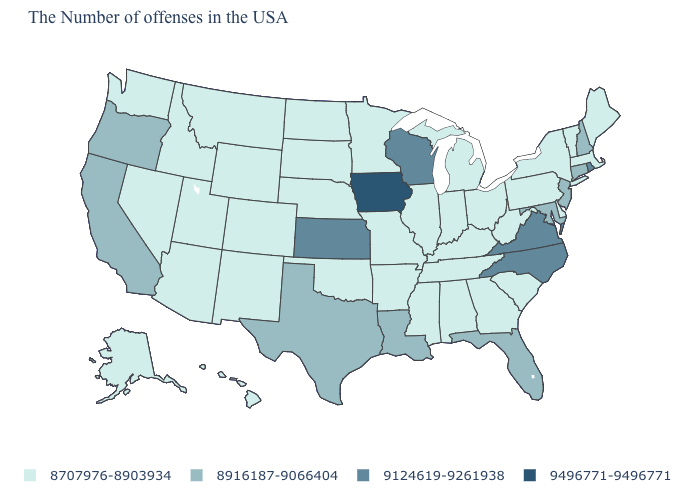What is the highest value in the South ?
Answer briefly. 9124619-9261938. Name the states that have a value in the range 8707976-8903934?
Write a very short answer. Maine, Massachusetts, Vermont, New York, Delaware, Pennsylvania, South Carolina, West Virginia, Ohio, Georgia, Michigan, Kentucky, Indiana, Alabama, Tennessee, Illinois, Mississippi, Missouri, Arkansas, Minnesota, Nebraska, Oklahoma, South Dakota, North Dakota, Wyoming, Colorado, New Mexico, Utah, Montana, Arizona, Idaho, Nevada, Washington, Alaska, Hawaii. What is the value of California?
Be succinct. 8916187-9066404. What is the value of Vermont?
Be succinct. 8707976-8903934. How many symbols are there in the legend?
Write a very short answer. 4. Among the states that border New Mexico , does Arizona have the lowest value?
Short answer required. Yes. Among the states that border Colorado , does Nebraska have the lowest value?
Keep it brief. Yes. Does Missouri have the lowest value in the MidWest?
Quick response, please. Yes. What is the lowest value in the South?
Write a very short answer. 8707976-8903934. How many symbols are there in the legend?
Keep it brief. 4. What is the value of Arkansas?
Keep it brief. 8707976-8903934. Among the states that border Nevada , does Utah have the highest value?
Concise answer only. No. Name the states that have a value in the range 8707976-8903934?
Quick response, please. Maine, Massachusetts, Vermont, New York, Delaware, Pennsylvania, South Carolina, West Virginia, Ohio, Georgia, Michigan, Kentucky, Indiana, Alabama, Tennessee, Illinois, Mississippi, Missouri, Arkansas, Minnesota, Nebraska, Oklahoma, South Dakota, North Dakota, Wyoming, Colorado, New Mexico, Utah, Montana, Arizona, Idaho, Nevada, Washington, Alaska, Hawaii. Does North Dakota have the highest value in the USA?
Keep it brief. No. Among the states that border Massachusetts , does Connecticut have the lowest value?
Answer briefly. No. 